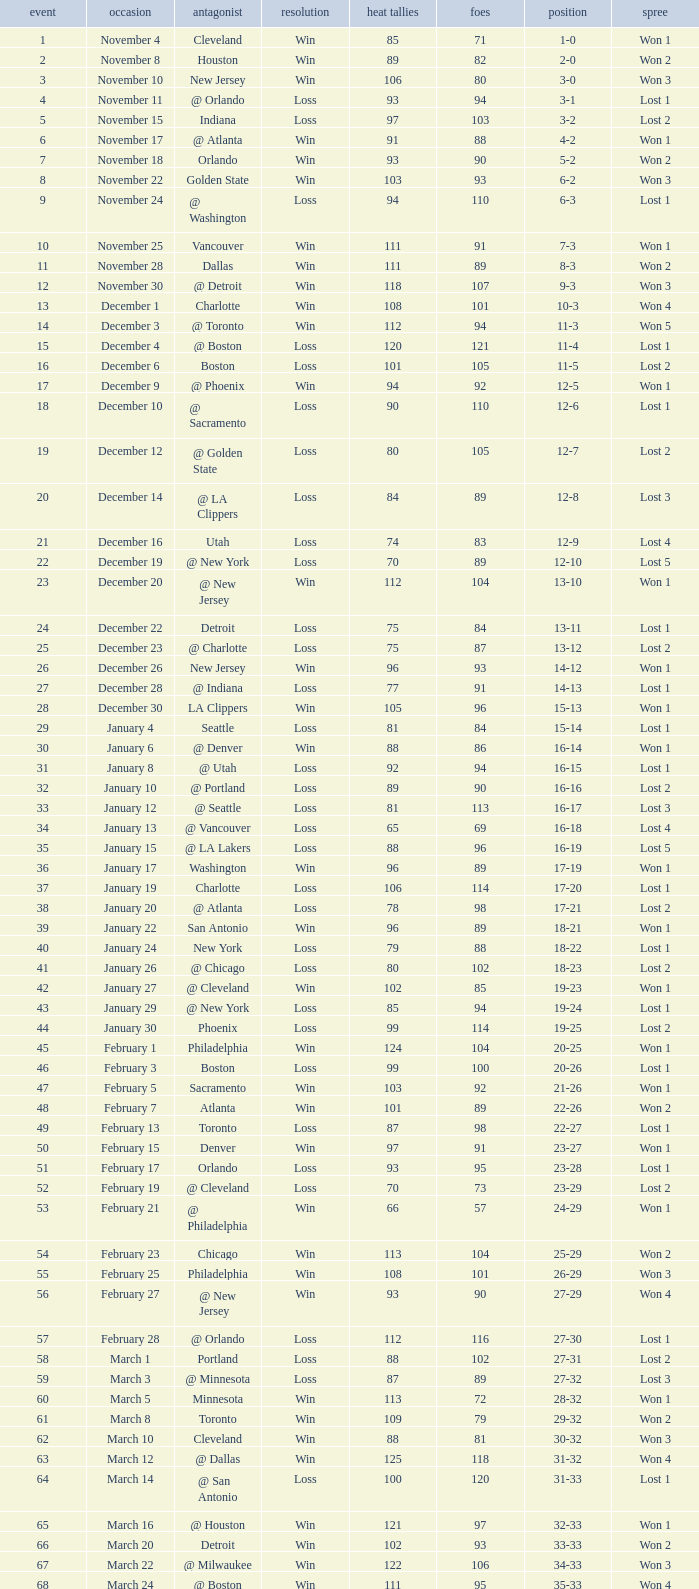What is the highest Game, when Opponents is less than 80, and when Record is "1-0"? 1.0. 